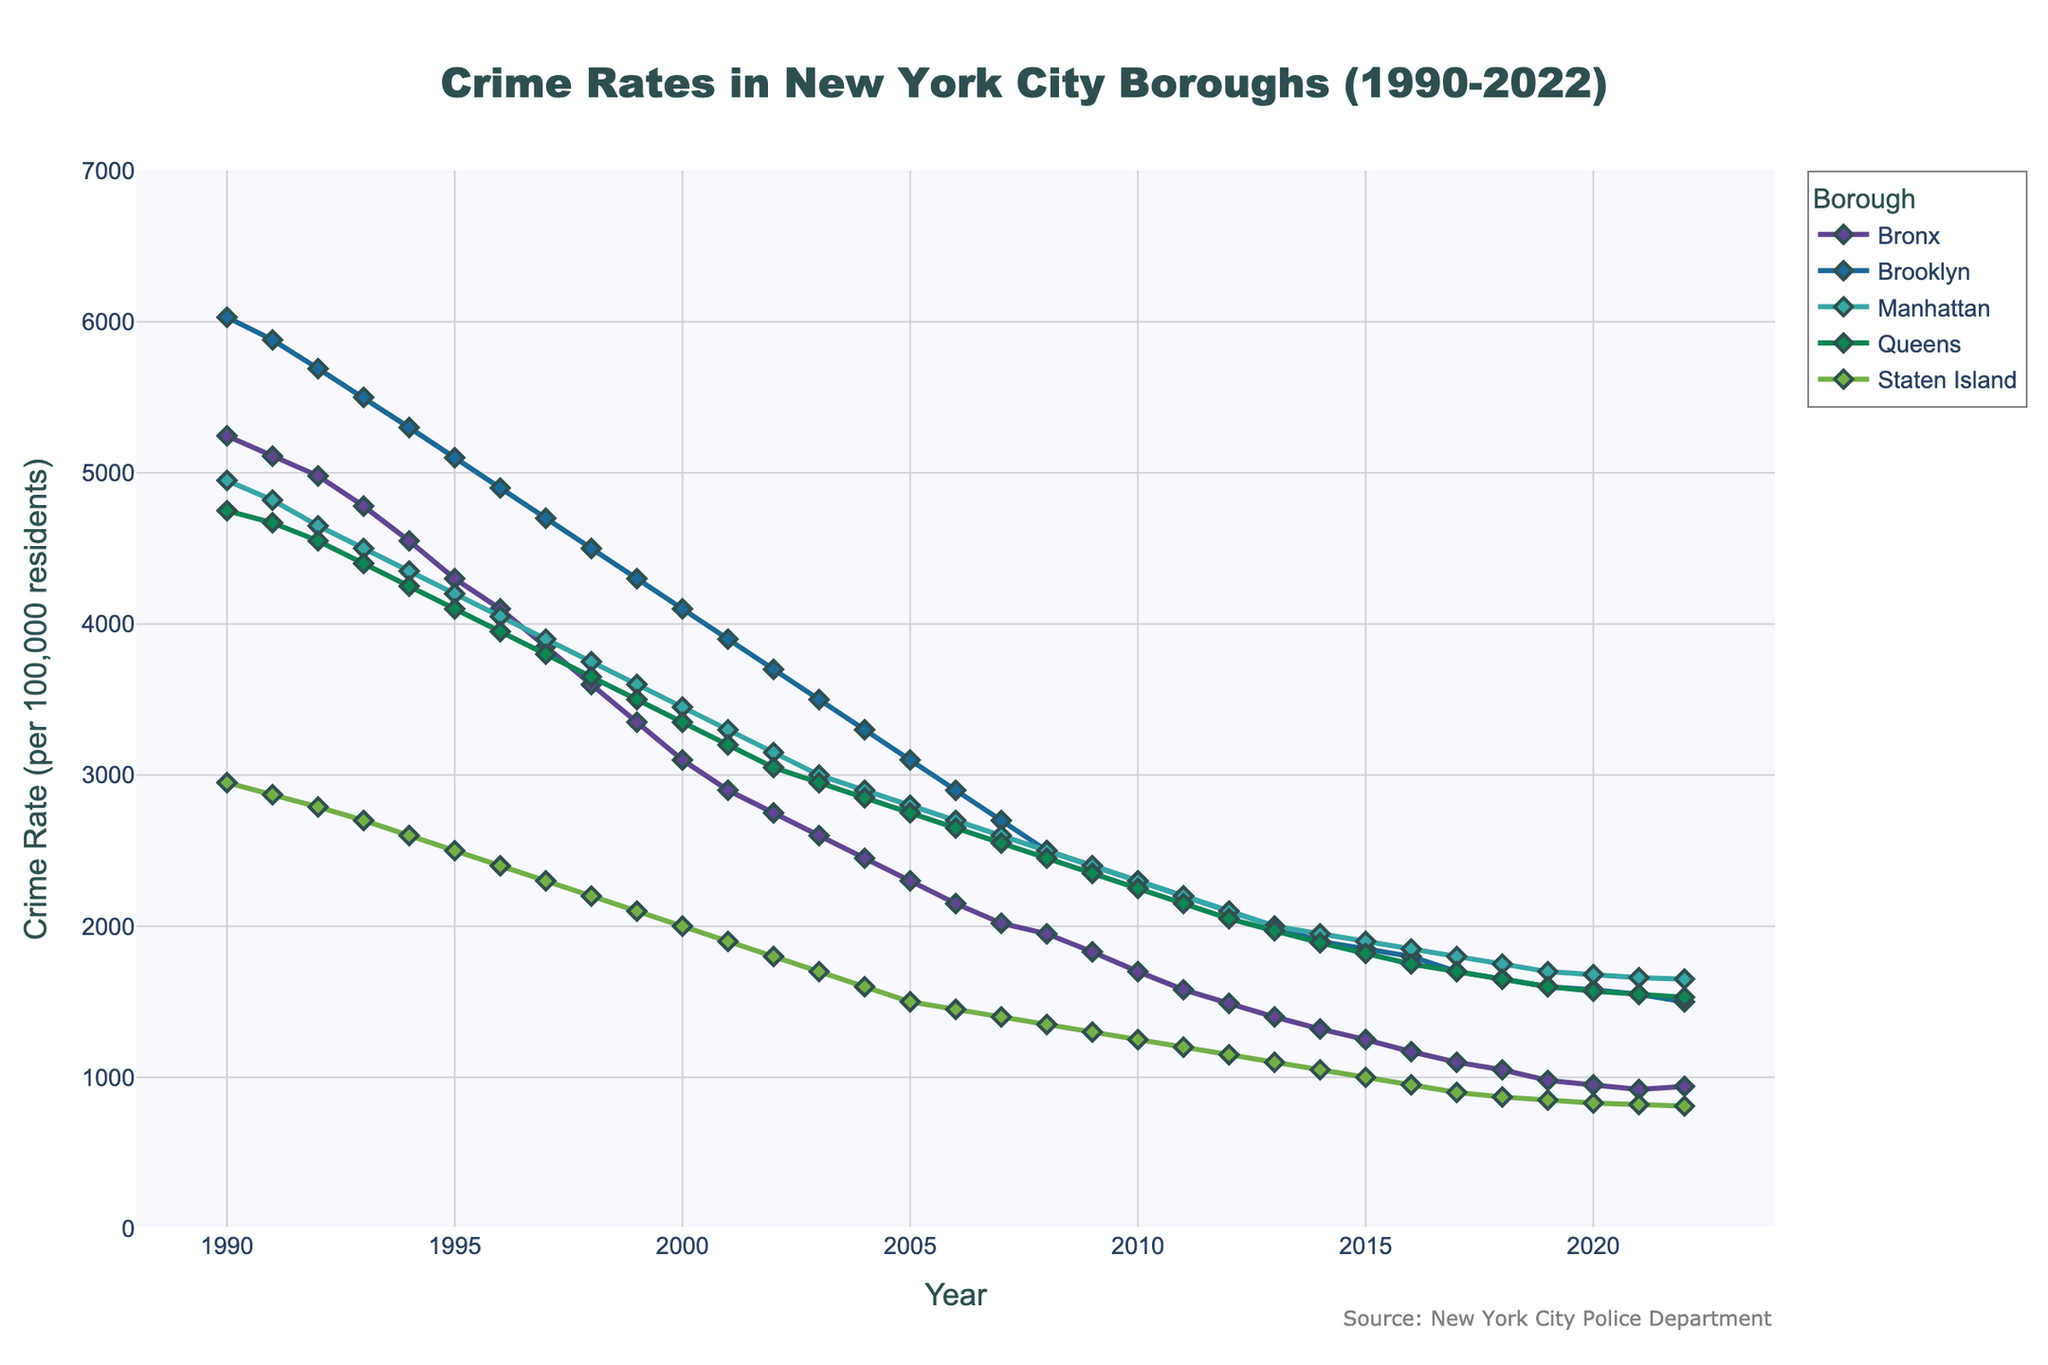What is the title of the plot? The title of the plot is often found at the top and it describes the content of the figure. By reading the title, you can understand that the plot is about crime rates in New York City boroughs over a specific period.
Answer: Crime Rates in New York City Boroughs (1990-2022) What is the range of years displayed on the x-axis? The x-axis usually represents the time in a time series plot, and you can identify the range by looking at the start and end points of the axis.
Answer: 1990-2022 Which borough had the highest crime rate in 1990? To answer this, observe the height of the lines for the year 1990 and identify which borough's line is the highest.
Answer: Brooklyn How did the crime rate in the Bronx change from 1990 to 2022? Observe the trajectory of the line for the Bronx from 1990 to 2022. A decreasing trend indicates a reduction in crime rate.
Answer: Decreased Which borough had the smallest decrease in crime rate from 1990 to 2022? Compare the heights of the lines for each borough between 1990 and 2022. Look for the line with the least vertical change.
Answer: Brooklyn How do the crime rates in Manhattan and Staten Island compare in 2022? Look at the heights of the lines for Manhattan and Staten Island in the year 2022 and compare them.
Answer: Manhattan is higher than Staten Island Which borough showed the most consistent decline in crime rate without significant fluctuations? Look for the line that declines steadily without noticeable peaks or troughs.
Answer: Manhattan What is the average crime rate in Queens during the 1990s (1990-1999)? Add the crime rates for Queens from 1990 to 1999 and divide by the number of years (10) to find the average.
Answer: (4750+4670+4550+4400+4250+4100+3950+3800+3650+3500)/10 = 4162 Which two boroughs had nearly identical crime rates in 2022? Compare the end points of each borough's line in the year 2022. Look for two lines that are very close to each other.
Answer: Queens and Brooklyn In which year did the Bronx's crime rate first drop below 2000? Follow the line for the Bronx and find the first point where it falls below the 2000 mark on the y-axis.
Answer: 2007 